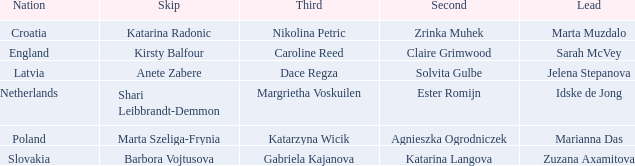What is the name of the third who has Barbora Vojtusova as Skip? Gabriela Kajanova. 